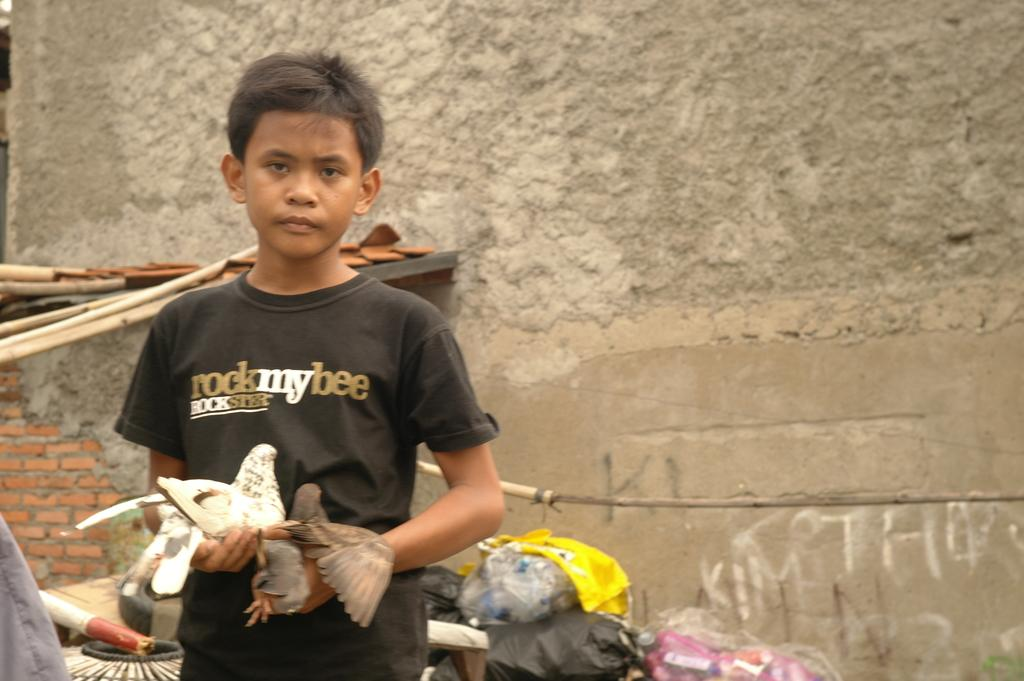Who is the main subject in the image? There is a boy in the image. What is the boy wearing? The boy is wearing a black t-shirt. What is the boy holding in the image? The boy is holding birds. What can be seen behind the boy? There are items visible behind the boy. What is the background of the image? There is a wall behind the boy. What type of comb is the boy using to groom the birds in the image? There is no comb present in the image, and the boy is not grooming the birds. 